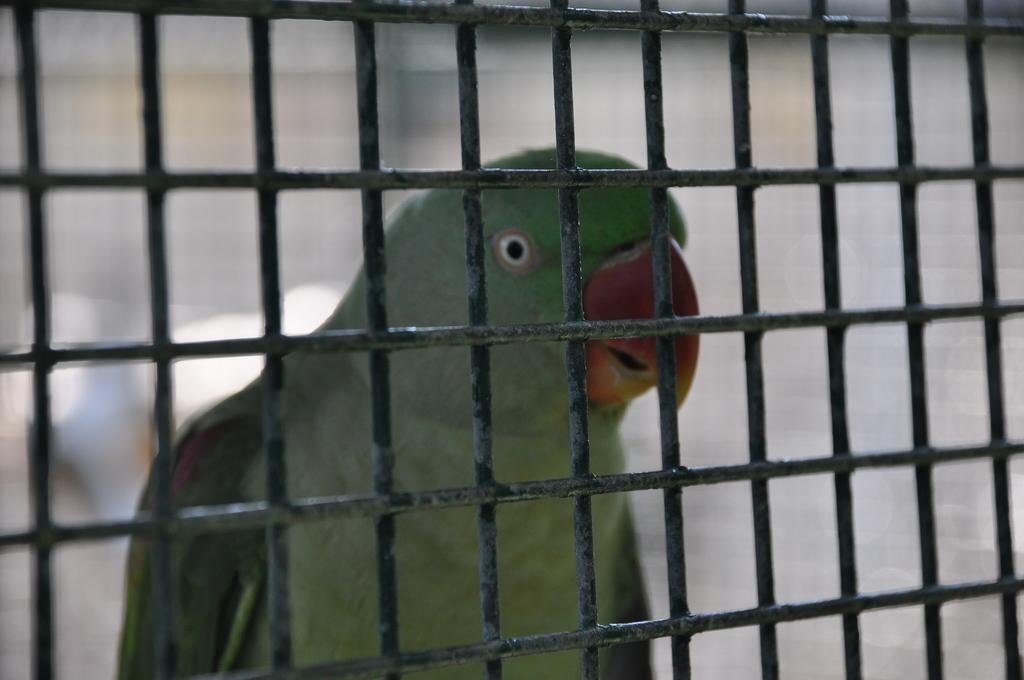What is the main object in the picture? There is a black mesh in the picture. What is located behind the mesh? There is a parrot behind the mesh. How is the parrot described? The parrot is described as cute. What type of plate is being used by the parrot in the image? There is no plate present in the image; the parrot is behind a black mesh. 